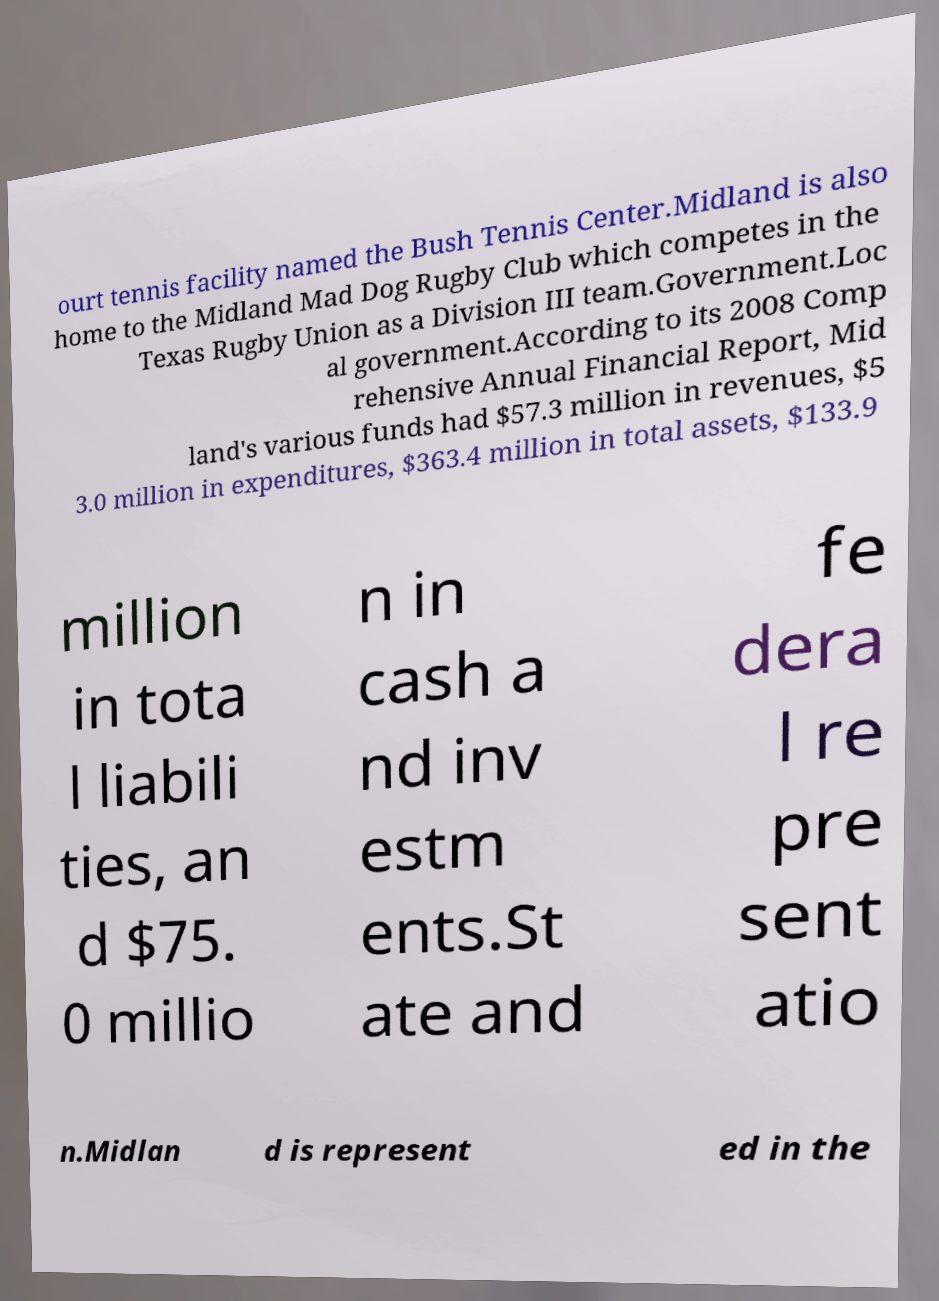Please identify and transcribe the text found in this image. ourt tennis facility named the Bush Tennis Center.Midland is also home to the Midland Mad Dog Rugby Club which competes in the Texas Rugby Union as a Division III team.Government.Loc al government.According to its 2008 Comp rehensive Annual Financial Report, Mid land's various funds had $57.3 million in revenues, $5 3.0 million in expenditures, $363.4 million in total assets, $133.9 million in tota l liabili ties, an d $75. 0 millio n in cash a nd inv estm ents.St ate and fe dera l re pre sent atio n.Midlan d is represent ed in the 